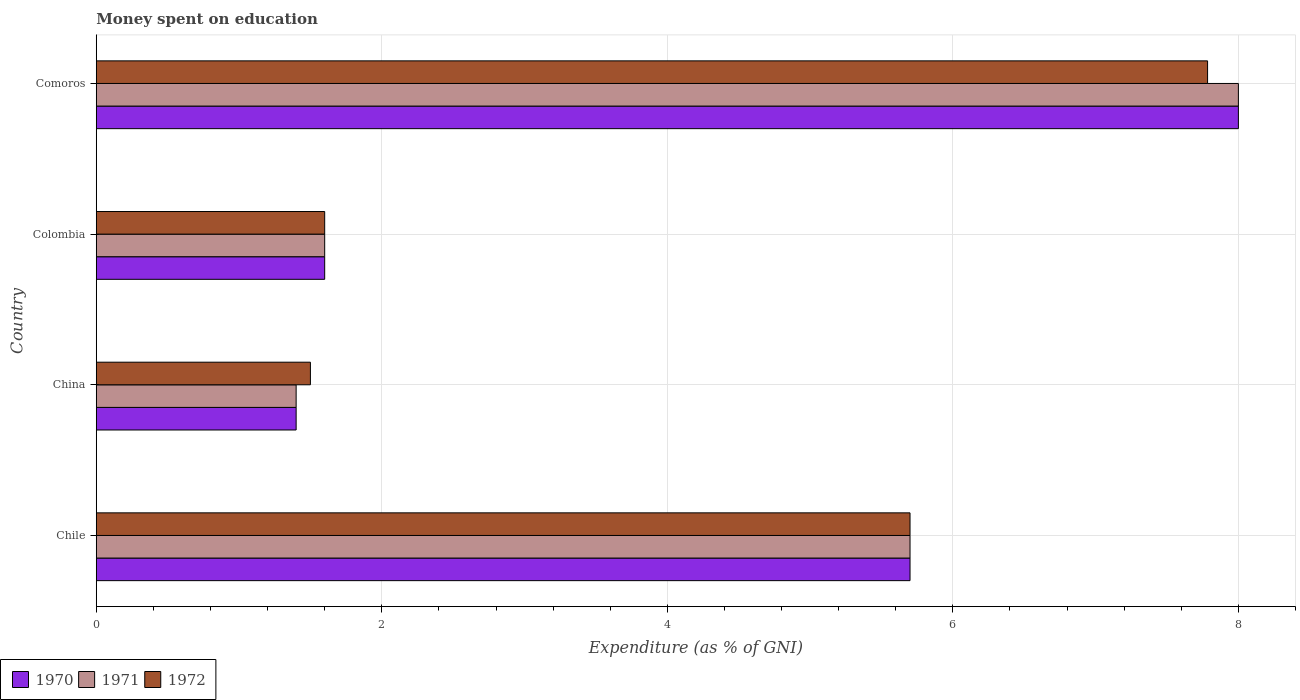How many different coloured bars are there?
Keep it short and to the point. 3. How many bars are there on the 4th tick from the top?
Your response must be concise. 3. How many bars are there on the 1st tick from the bottom?
Make the answer very short. 3. What is the label of the 2nd group of bars from the top?
Make the answer very short. Colombia. In how many cases, is the number of bars for a given country not equal to the number of legend labels?
Keep it short and to the point. 0. What is the amount of money spent on education in 1972 in Colombia?
Your response must be concise. 1.6. In which country was the amount of money spent on education in 1972 maximum?
Give a very brief answer. Comoros. In which country was the amount of money spent on education in 1970 minimum?
Ensure brevity in your answer.  China. What is the difference between the amount of money spent on education in 1971 in Chile and that in Comoros?
Offer a very short reply. -2.3. What is the difference between the amount of money spent on education in 1971 in China and the amount of money spent on education in 1972 in Chile?
Your answer should be very brief. -4.3. What is the average amount of money spent on education in 1971 per country?
Ensure brevity in your answer.  4.17. What is the ratio of the amount of money spent on education in 1971 in Chile to that in Comoros?
Make the answer very short. 0.71. Is the amount of money spent on education in 1972 in Chile less than that in China?
Ensure brevity in your answer.  No. What is the difference between the highest and the lowest amount of money spent on education in 1972?
Give a very brief answer. 6.28. In how many countries, is the amount of money spent on education in 1971 greater than the average amount of money spent on education in 1971 taken over all countries?
Your answer should be compact. 2. What does the 1st bar from the top in Comoros represents?
Your answer should be very brief. 1972. Is it the case that in every country, the sum of the amount of money spent on education in 1972 and amount of money spent on education in 1971 is greater than the amount of money spent on education in 1970?
Give a very brief answer. Yes. How many bars are there?
Offer a terse response. 12. Are all the bars in the graph horizontal?
Offer a terse response. Yes. Are the values on the major ticks of X-axis written in scientific E-notation?
Give a very brief answer. No. Does the graph contain grids?
Make the answer very short. Yes. Where does the legend appear in the graph?
Your answer should be compact. Bottom left. What is the title of the graph?
Offer a very short reply. Money spent on education. Does "1961" appear as one of the legend labels in the graph?
Give a very brief answer. No. What is the label or title of the X-axis?
Ensure brevity in your answer.  Expenditure (as % of GNI). What is the Expenditure (as % of GNI) of 1972 in Chile?
Your answer should be very brief. 5.7. What is the Expenditure (as % of GNI) in 1970 in Colombia?
Offer a terse response. 1.6. What is the Expenditure (as % of GNI) in 1972 in Colombia?
Offer a very short reply. 1.6. What is the Expenditure (as % of GNI) of 1971 in Comoros?
Offer a terse response. 8. What is the Expenditure (as % of GNI) of 1972 in Comoros?
Offer a terse response. 7.78. Across all countries, what is the maximum Expenditure (as % of GNI) of 1971?
Your response must be concise. 8. Across all countries, what is the maximum Expenditure (as % of GNI) of 1972?
Offer a terse response. 7.78. Across all countries, what is the minimum Expenditure (as % of GNI) in 1972?
Keep it short and to the point. 1.5. What is the total Expenditure (as % of GNI) in 1970 in the graph?
Ensure brevity in your answer.  16.7. What is the total Expenditure (as % of GNI) of 1972 in the graph?
Your answer should be very brief. 16.58. What is the difference between the Expenditure (as % of GNI) in 1972 in Chile and that in China?
Provide a short and direct response. 4.2. What is the difference between the Expenditure (as % of GNI) in 1970 in Chile and that in Colombia?
Your answer should be compact. 4.1. What is the difference between the Expenditure (as % of GNI) in 1970 in Chile and that in Comoros?
Your response must be concise. -2.3. What is the difference between the Expenditure (as % of GNI) of 1971 in Chile and that in Comoros?
Provide a succinct answer. -2.3. What is the difference between the Expenditure (as % of GNI) in 1972 in Chile and that in Comoros?
Keep it short and to the point. -2.08. What is the difference between the Expenditure (as % of GNI) in 1971 in China and that in Colombia?
Your answer should be very brief. -0.2. What is the difference between the Expenditure (as % of GNI) of 1972 in China and that in Colombia?
Keep it short and to the point. -0.1. What is the difference between the Expenditure (as % of GNI) of 1970 in China and that in Comoros?
Offer a terse response. -6.6. What is the difference between the Expenditure (as % of GNI) in 1971 in China and that in Comoros?
Ensure brevity in your answer.  -6.6. What is the difference between the Expenditure (as % of GNI) of 1972 in China and that in Comoros?
Provide a short and direct response. -6.28. What is the difference between the Expenditure (as % of GNI) in 1971 in Colombia and that in Comoros?
Your answer should be compact. -6.4. What is the difference between the Expenditure (as % of GNI) of 1972 in Colombia and that in Comoros?
Provide a succinct answer. -6.18. What is the difference between the Expenditure (as % of GNI) in 1970 in Chile and the Expenditure (as % of GNI) in 1972 in Colombia?
Keep it short and to the point. 4.1. What is the difference between the Expenditure (as % of GNI) of 1971 in Chile and the Expenditure (as % of GNI) of 1972 in Colombia?
Offer a very short reply. 4.1. What is the difference between the Expenditure (as % of GNI) in 1970 in Chile and the Expenditure (as % of GNI) in 1971 in Comoros?
Ensure brevity in your answer.  -2.3. What is the difference between the Expenditure (as % of GNI) in 1970 in Chile and the Expenditure (as % of GNI) in 1972 in Comoros?
Your answer should be compact. -2.08. What is the difference between the Expenditure (as % of GNI) in 1971 in Chile and the Expenditure (as % of GNI) in 1972 in Comoros?
Give a very brief answer. -2.08. What is the difference between the Expenditure (as % of GNI) of 1970 in China and the Expenditure (as % of GNI) of 1971 in Colombia?
Offer a very short reply. -0.2. What is the difference between the Expenditure (as % of GNI) in 1970 in China and the Expenditure (as % of GNI) in 1972 in Colombia?
Provide a short and direct response. -0.2. What is the difference between the Expenditure (as % of GNI) of 1971 in China and the Expenditure (as % of GNI) of 1972 in Colombia?
Ensure brevity in your answer.  -0.2. What is the difference between the Expenditure (as % of GNI) of 1970 in China and the Expenditure (as % of GNI) of 1972 in Comoros?
Offer a very short reply. -6.38. What is the difference between the Expenditure (as % of GNI) in 1971 in China and the Expenditure (as % of GNI) in 1972 in Comoros?
Give a very brief answer. -6.38. What is the difference between the Expenditure (as % of GNI) in 1970 in Colombia and the Expenditure (as % of GNI) in 1972 in Comoros?
Give a very brief answer. -6.18. What is the difference between the Expenditure (as % of GNI) of 1971 in Colombia and the Expenditure (as % of GNI) of 1972 in Comoros?
Your answer should be very brief. -6.18. What is the average Expenditure (as % of GNI) of 1970 per country?
Make the answer very short. 4.17. What is the average Expenditure (as % of GNI) in 1971 per country?
Your response must be concise. 4.17. What is the average Expenditure (as % of GNI) in 1972 per country?
Make the answer very short. 4.15. What is the difference between the Expenditure (as % of GNI) of 1970 and Expenditure (as % of GNI) of 1971 in Chile?
Make the answer very short. 0. What is the difference between the Expenditure (as % of GNI) in 1970 and Expenditure (as % of GNI) in 1972 in Chile?
Give a very brief answer. 0. What is the difference between the Expenditure (as % of GNI) of 1971 and Expenditure (as % of GNI) of 1972 in Chile?
Ensure brevity in your answer.  0. What is the difference between the Expenditure (as % of GNI) in 1970 and Expenditure (as % of GNI) in 1972 in China?
Keep it short and to the point. -0.1. What is the difference between the Expenditure (as % of GNI) in 1970 and Expenditure (as % of GNI) in 1972 in Colombia?
Keep it short and to the point. 0. What is the difference between the Expenditure (as % of GNI) of 1971 and Expenditure (as % of GNI) of 1972 in Colombia?
Offer a terse response. 0. What is the difference between the Expenditure (as % of GNI) in 1970 and Expenditure (as % of GNI) in 1972 in Comoros?
Offer a very short reply. 0.22. What is the difference between the Expenditure (as % of GNI) of 1971 and Expenditure (as % of GNI) of 1972 in Comoros?
Offer a very short reply. 0.22. What is the ratio of the Expenditure (as % of GNI) in 1970 in Chile to that in China?
Provide a short and direct response. 4.07. What is the ratio of the Expenditure (as % of GNI) of 1971 in Chile to that in China?
Your response must be concise. 4.07. What is the ratio of the Expenditure (as % of GNI) of 1972 in Chile to that in China?
Provide a short and direct response. 3.8. What is the ratio of the Expenditure (as % of GNI) of 1970 in Chile to that in Colombia?
Your response must be concise. 3.56. What is the ratio of the Expenditure (as % of GNI) in 1971 in Chile to that in Colombia?
Your answer should be compact. 3.56. What is the ratio of the Expenditure (as % of GNI) of 1972 in Chile to that in Colombia?
Provide a succinct answer. 3.56. What is the ratio of the Expenditure (as % of GNI) of 1970 in Chile to that in Comoros?
Your answer should be very brief. 0.71. What is the ratio of the Expenditure (as % of GNI) in 1971 in Chile to that in Comoros?
Ensure brevity in your answer.  0.71. What is the ratio of the Expenditure (as % of GNI) of 1972 in Chile to that in Comoros?
Your answer should be compact. 0.73. What is the ratio of the Expenditure (as % of GNI) in 1970 in China to that in Colombia?
Your response must be concise. 0.88. What is the ratio of the Expenditure (as % of GNI) in 1971 in China to that in Colombia?
Make the answer very short. 0.88. What is the ratio of the Expenditure (as % of GNI) in 1972 in China to that in Colombia?
Ensure brevity in your answer.  0.94. What is the ratio of the Expenditure (as % of GNI) in 1970 in China to that in Comoros?
Offer a terse response. 0.17. What is the ratio of the Expenditure (as % of GNI) of 1971 in China to that in Comoros?
Keep it short and to the point. 0.17. What is the ratio of the Expenditure (as % of GNI) in 1972 in China to that in Comoros?
Offer a terse response. 0.19. What is the ratio of the Expenditure (as % of GNI) in 1970 in Colombia to that in Comoros?
Give a very brief answer. 0.2. What is the ratio of the Expenditure (as % of GNI) of 1971 in Colombia to that in Comoros?
Provide a short and direct response. 0.2. What is the ratio of the Expenditure (as % of GNI) in 1972 in Colombia to that in Comoros?
Your response must be concise. 0.21. What is the difference between the highest and the second highest Expenditure (as % of GNI) in 1972?
Offer a terse response. 2.08. What is the difference between the highest and the lowest Expenditure (as % of GNI) of 1971?
Your response must be concise. 6.6. What is the difference between the highest and the lowest Expenditure (as % of GNI) of 1972?
Your answer should be very brief. 6.28. 